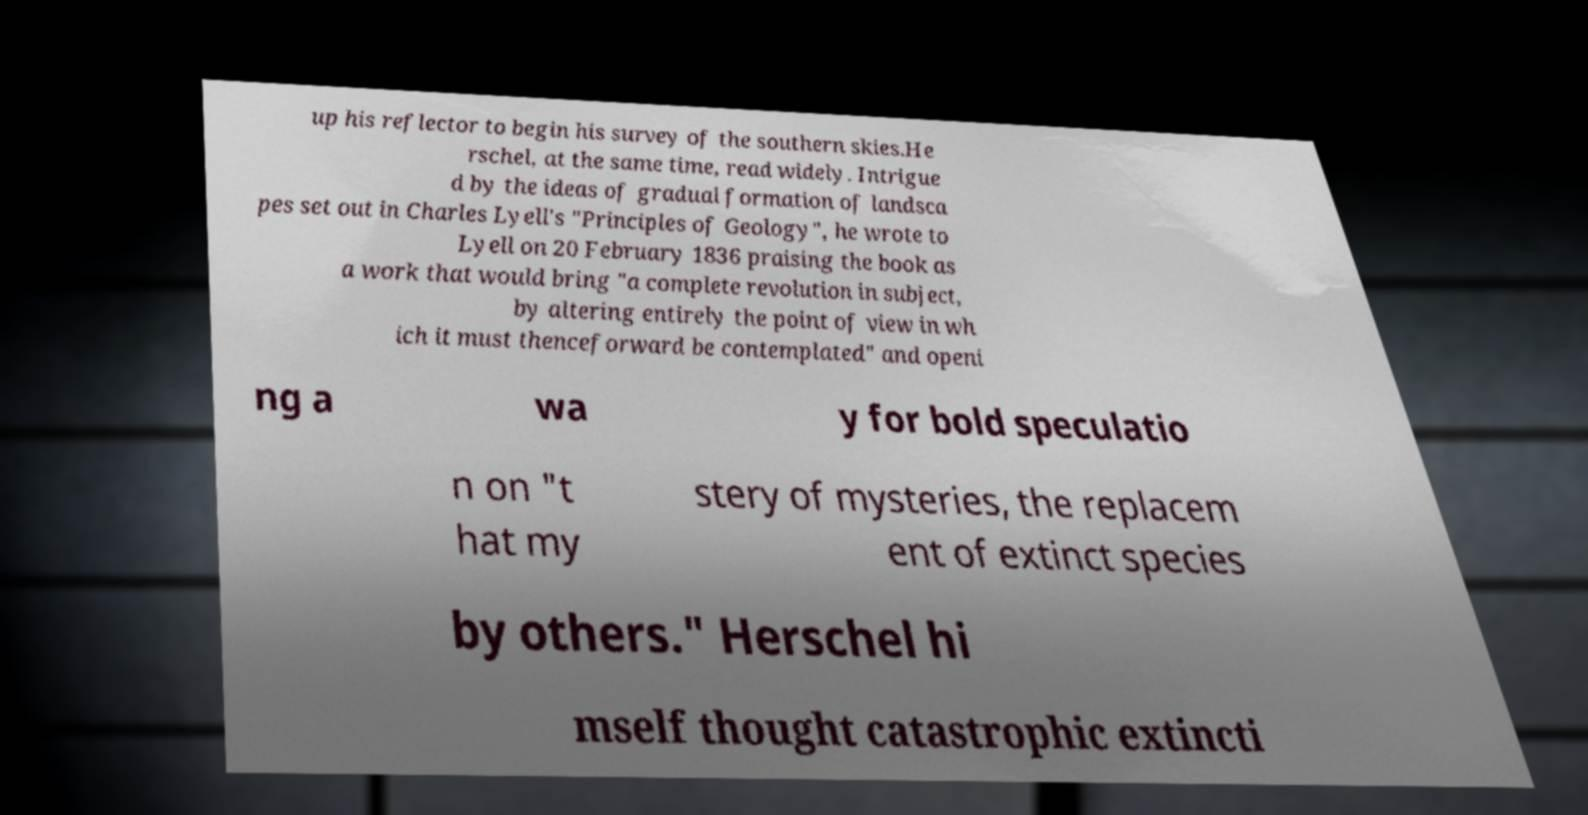Could you extract and type out the text from this image? up his reflector to begin his survey of the southern skies.He rschel, at the same time, read widely. Intrigue d by the ideas of gradual formation of landsca pes set out in Charles Lyell's "Principles of Geology", he wrote to Lyell on 20 February 1836 praising the book as a work that would bring "a complete revolution in subject, by altering entirely the point of view in wh ich it must thenceforward be contemplated" and openi ng a wa y for bold speculatio n on "t hat my stery of mysteries, the replacem ent of extinct species by others." Herschel hi mself thought catastrophic extincti 